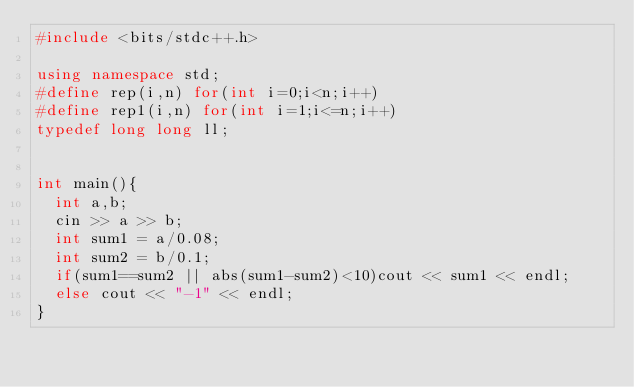<code> <loc_0><loc_0><loc_500><loc_500><_C++_>#include <bits/stdc++.h>

using namespace std;
#define rep(i,n) for(int i=0;i<n;i++)
#define rep1(i,n) for(int i=1;i<=n;i++)
typedef long long ll;


int main(){
  int a,b;
  cin >> a >> b;
  int sum1 = a/0.08;
  int sum2 = b/0.1;
  if(sum1==sum2 || abs(sum1-sum2)<10)cout << sum1 << endl;
  else cout << "-1" << endl;
}
</code> 